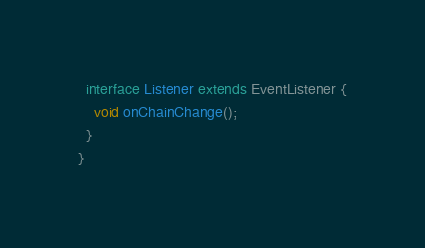Convert code to text. <code><loc_0><loc_0><loc_500><loc_500><_Java_>
  interface Listener extends EventListener {
    void onChainChange();
  }
}
</code> 